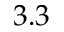Convert formula to latex. <formula><loc_0><loc_0><loc_500><loc_500>3 . 3</formula> 